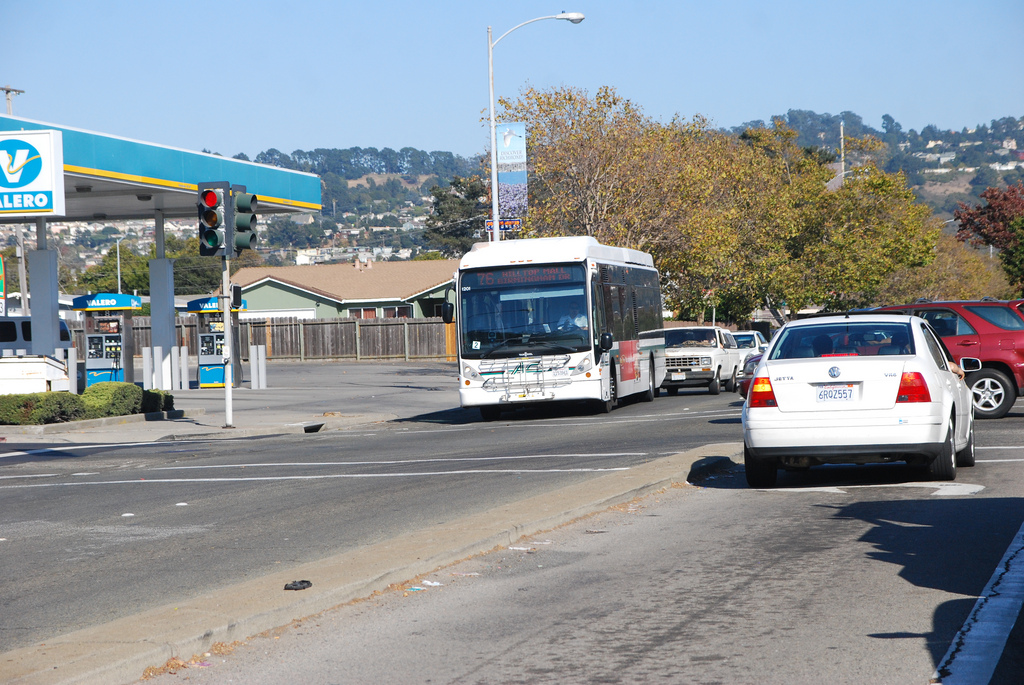Are there mirrors in the image? If you're referring to rearview or side mirrors on the vehicles, they are indeed visible; however, if you mean reflective mirrors like those in a bathroom or as street installations, there are none in the image. 